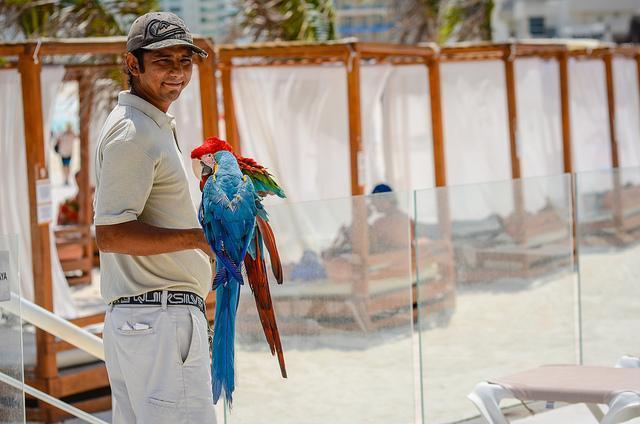How many birds is the man holding?
Give a very brief answer. 2. How many beds are in the photo?
Give a very brief answer. 3. How many boats are there?
Give a very brief answer. 0. 